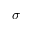Convert formula to latex. <formula><loc_0><loc_0><loc_500><loc_500>\sigma</formula> 